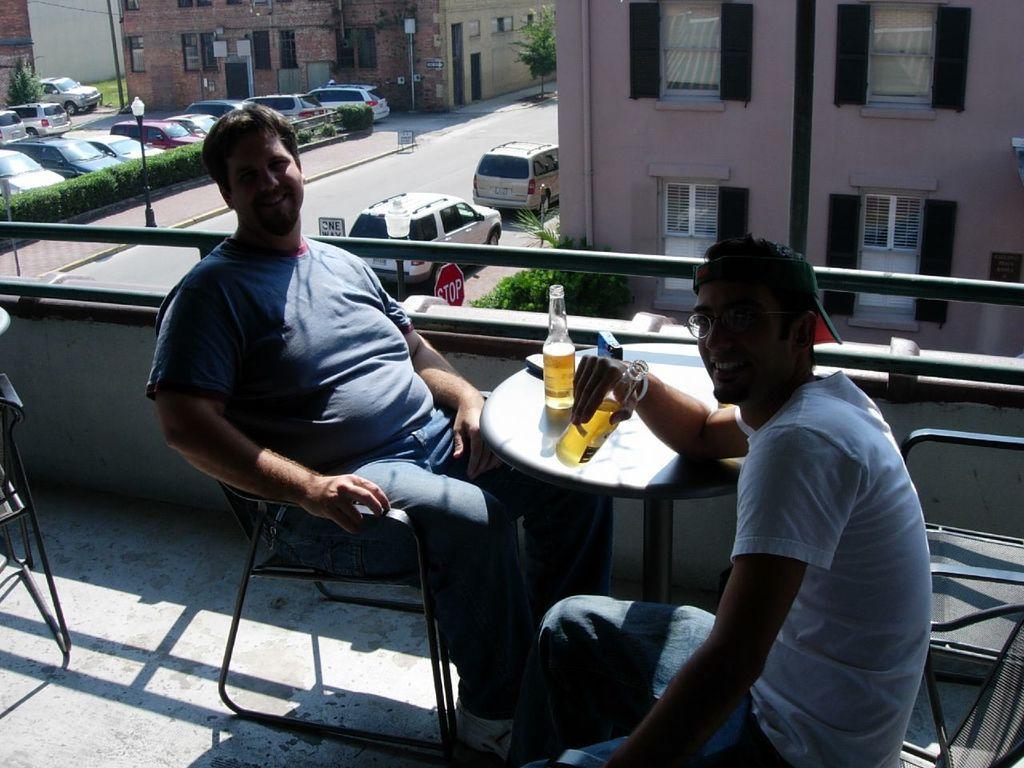How would you summarize this image in a sentence or two? We can see two men are sitting on the chairs at the table at the fence and on the table there is a wine bottle and objects and the right side man is holding a wine bottle in his hand. In the background there are vehicles on the road, plants, trees, buildings, windows, sign board poles, light poles and objects on the wall. 